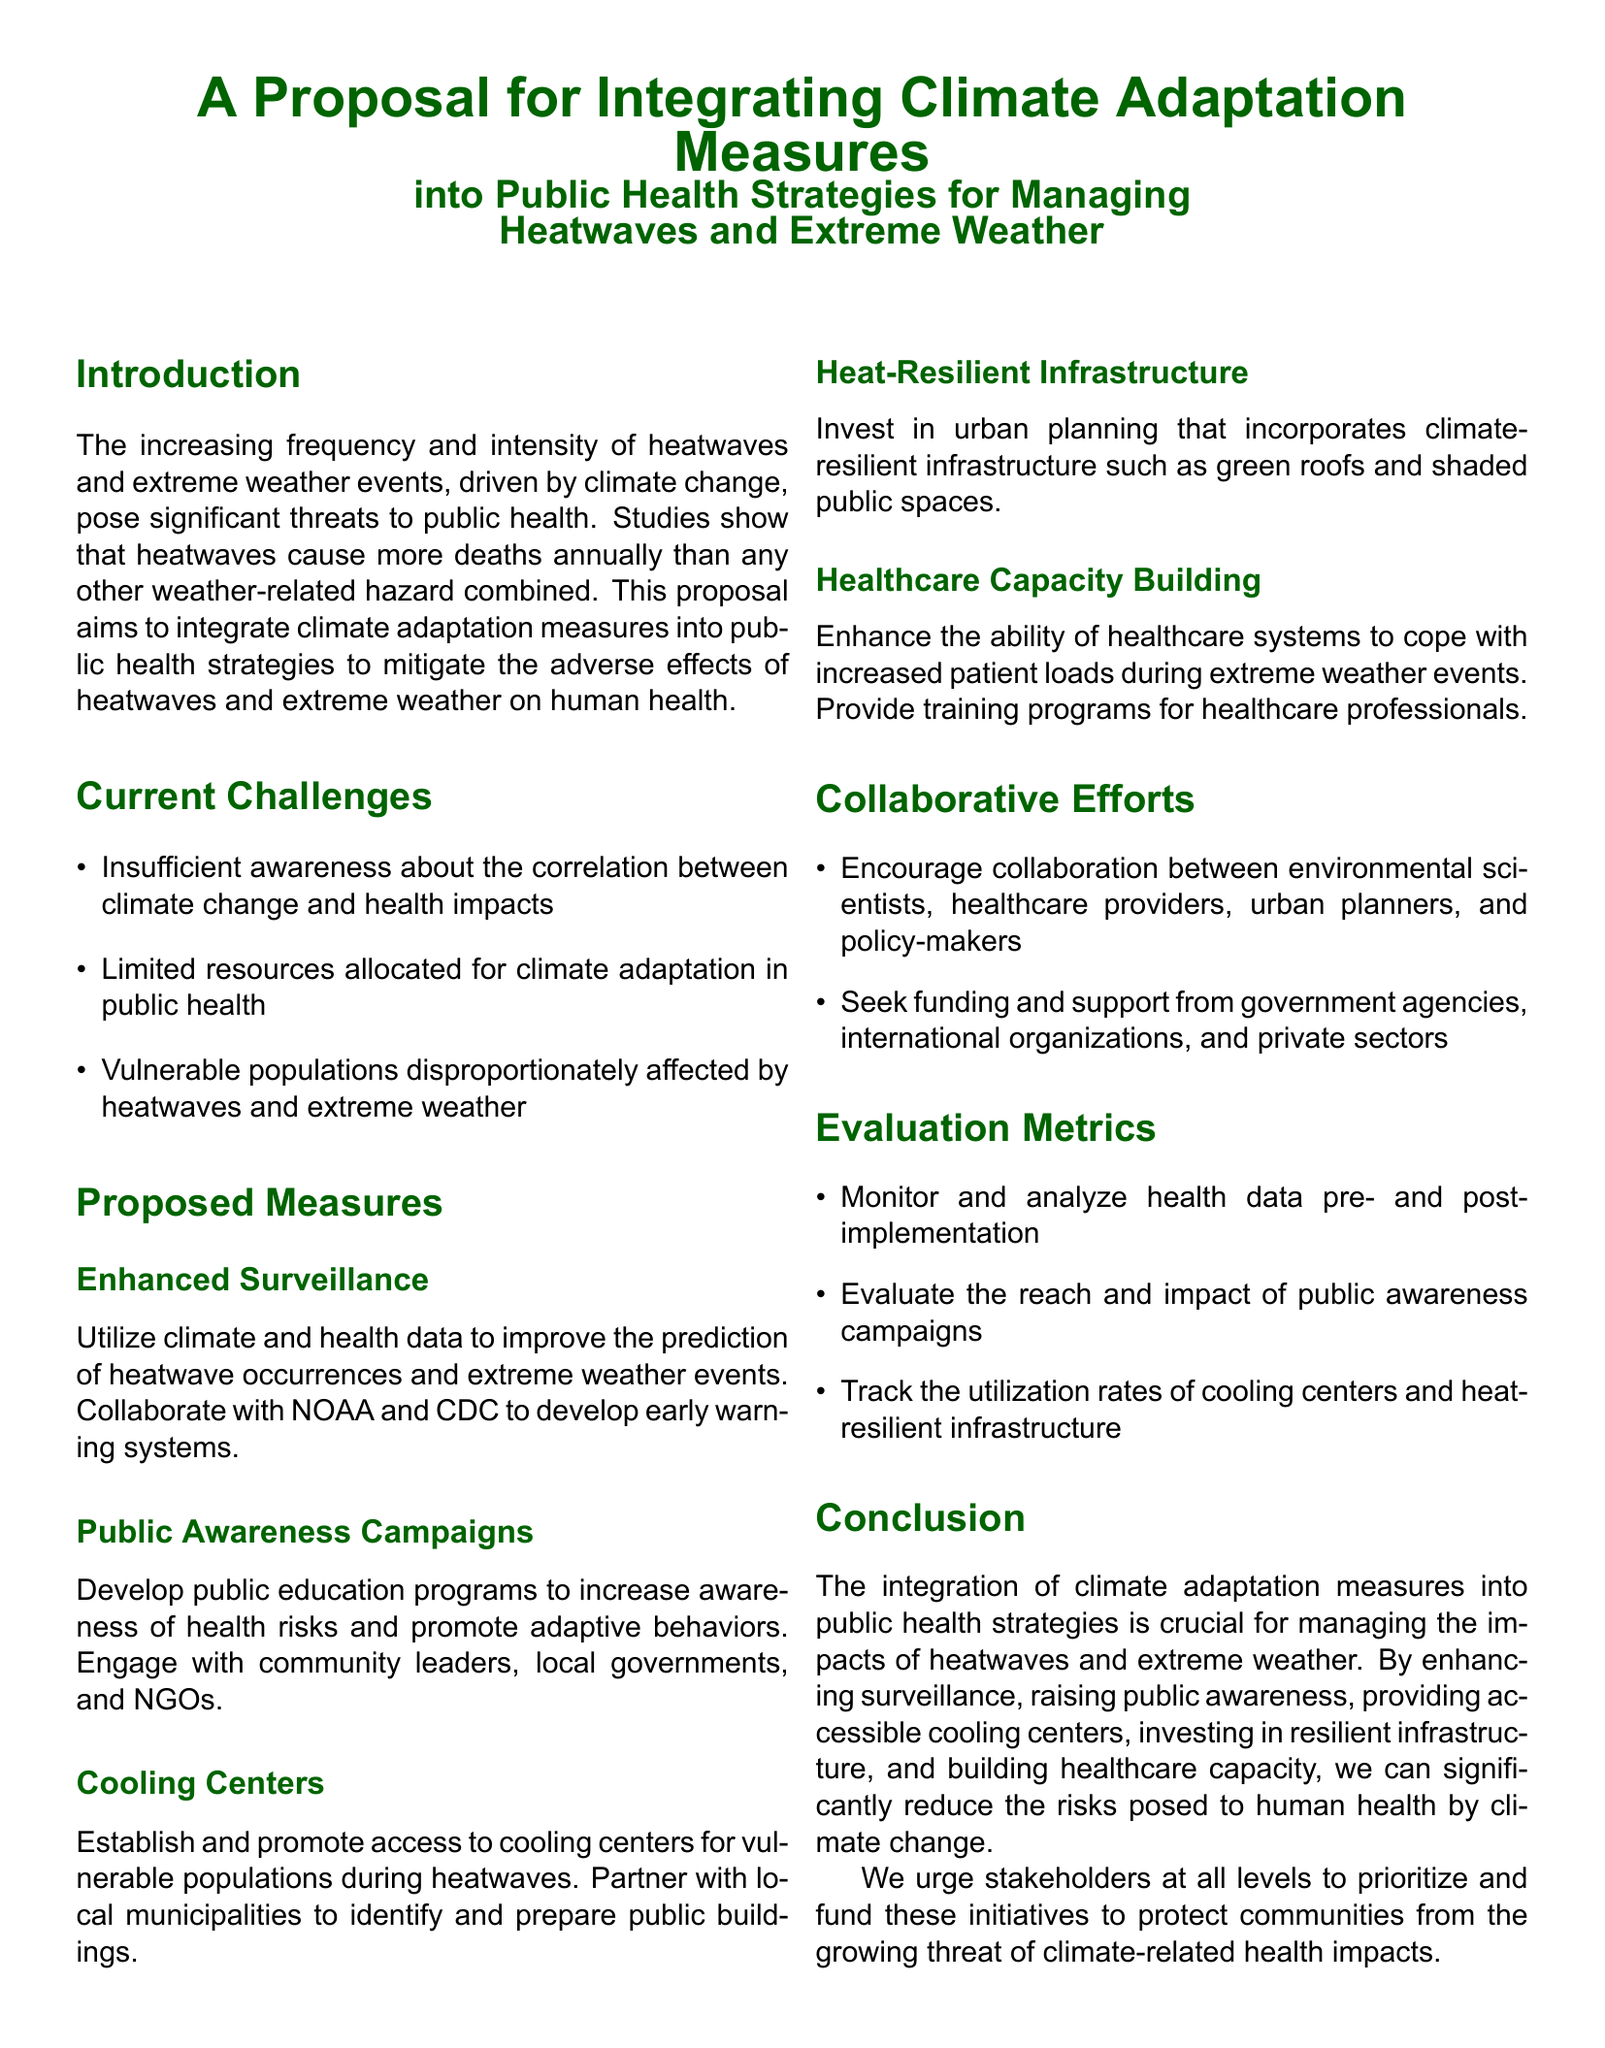What is the purpose of the proposal? The proposal aims to integrate climate adaptation measures into public health strategies to mitigate the adverse effects of heatwaves and extreme weather on human health.
Answer: Integrate climate adaptation measures What are the current challenges mentioned? The current challenges outlined in the proposal include insufficient awareness, limited resources, and vulnerable populations disproportionately affected.
Answer: Insufficient awareness, limited resources, vulnerable populations Which organizations are suggested for collaboration in enhanced surveillance? The proposal suggests collaboration with NOAA and CDC to develop early warning systems.
Answer: NOAA and CDC What is one measure proposed to assist vulnerable populations during heatwaves? The proposal suggests establishing and promoting access to cooling centers for vulnerable populations during heatwaves.
Answer: Cooling centers What type of infrastructure does the proposal recommend investing in? The proposal recommends investing in climate-resilient infrastructure such as green roofs and shaded public spaces.
Answer: Climate-resilient infrastructure How many evaluation metrics are listed in the proposal? The proposal lists three evaluation metrics for monitoring the effects of the suggested measures.
Answer: Three Which groups are encouraged to collaborate according to the proposal? The proposal encourages collaboration between environmental scientists, healthcare providers, urban planners, and policy-makers.
Answer: Environmental scientists, healthcare providers, urban planners, and policy-makers What urgency does the proposal express for stakeholders? The proposal urges stakeholders at all levels to prioritize and fund initiatives to protect communities from climate-related health impacts.
Answer: Prioritize and fund initiatives 